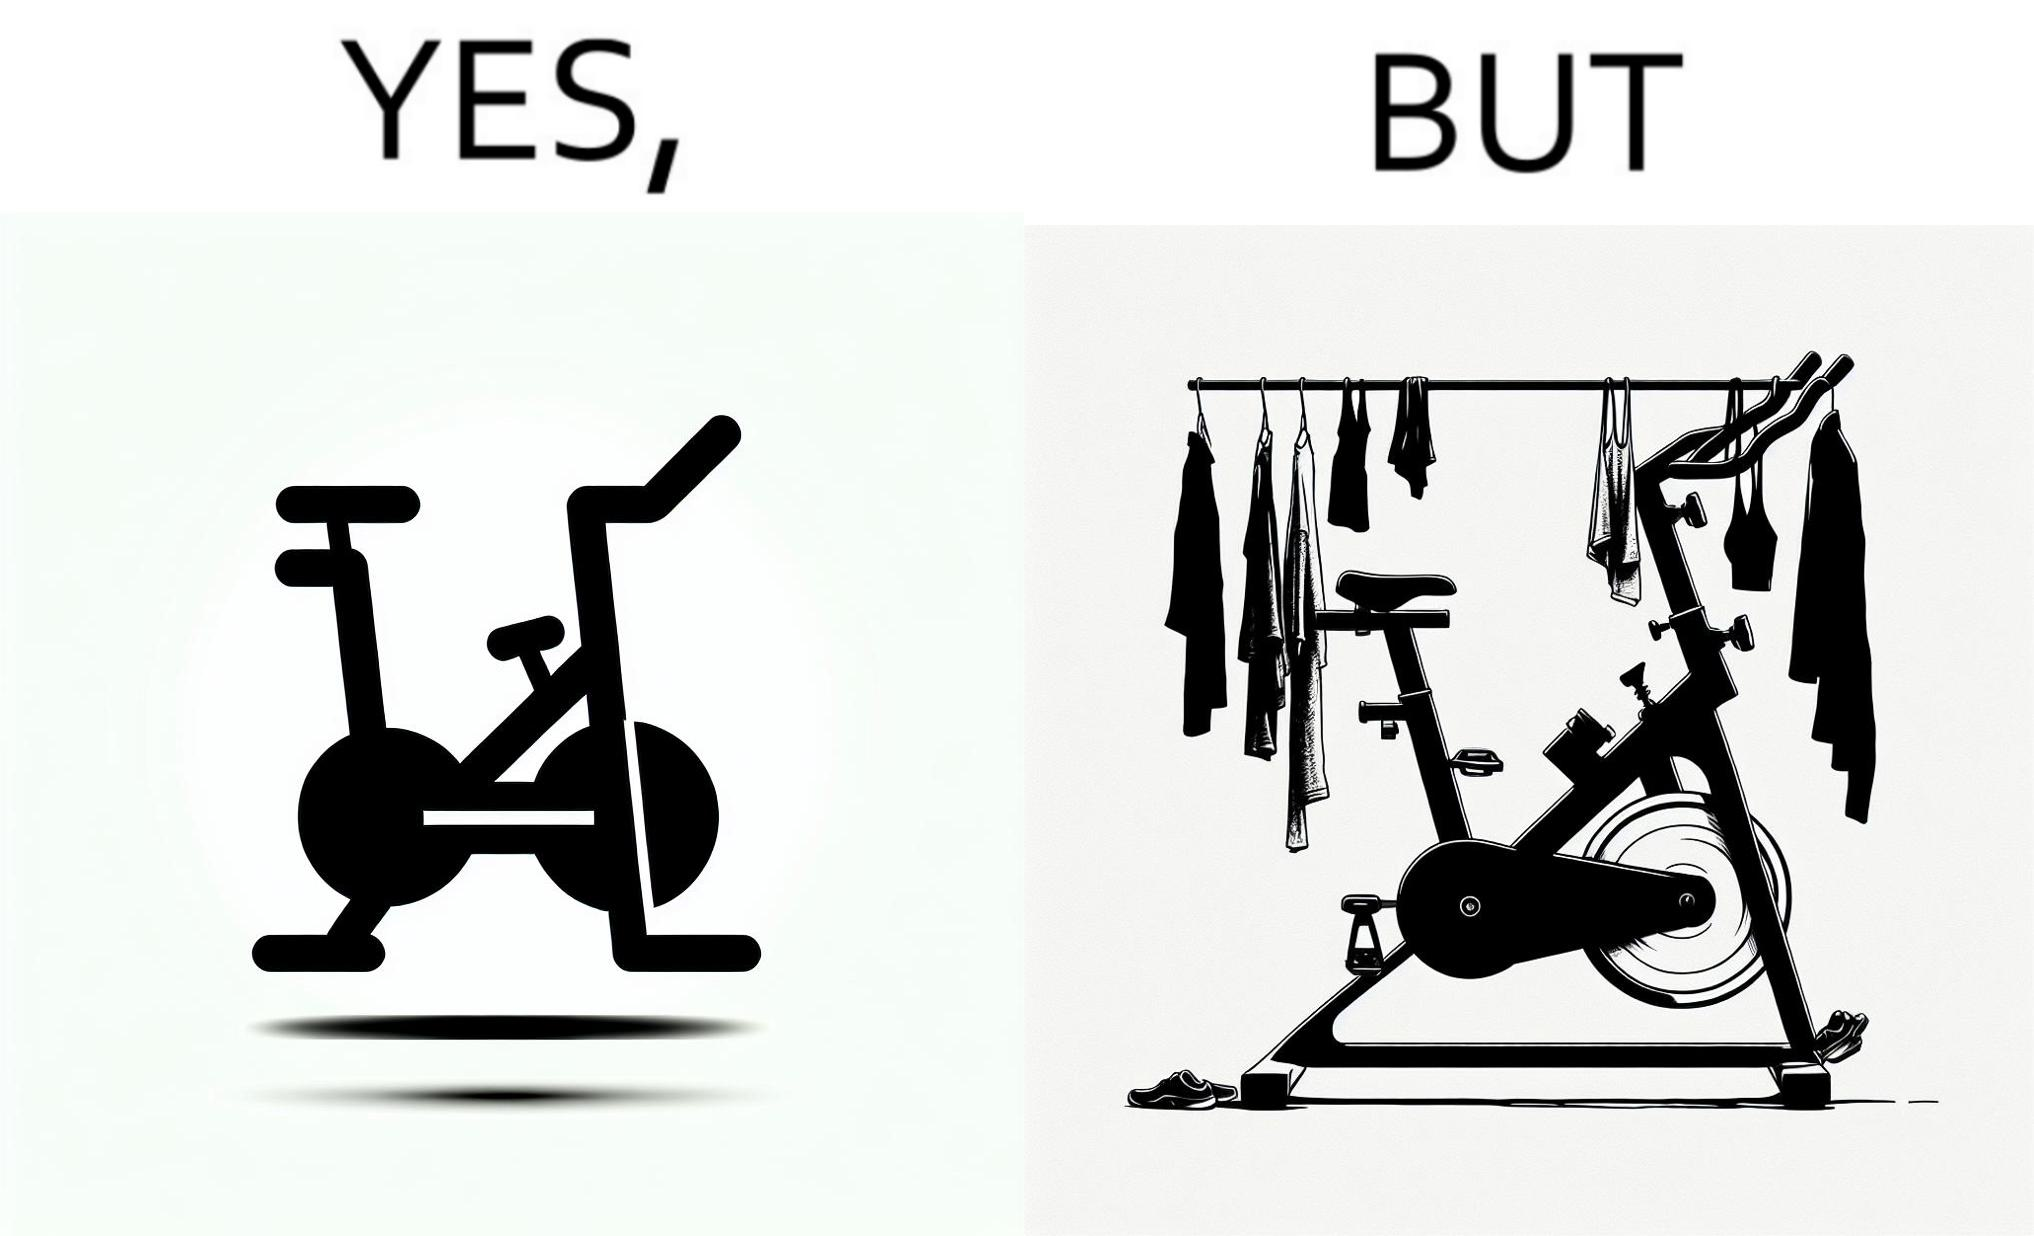Describe the satirical element in this image. The images are funny since they show an exercise bike has been bought but is not being used for its purpose, that is, exercising. It is rather being used to hang clothes, bags and other items 